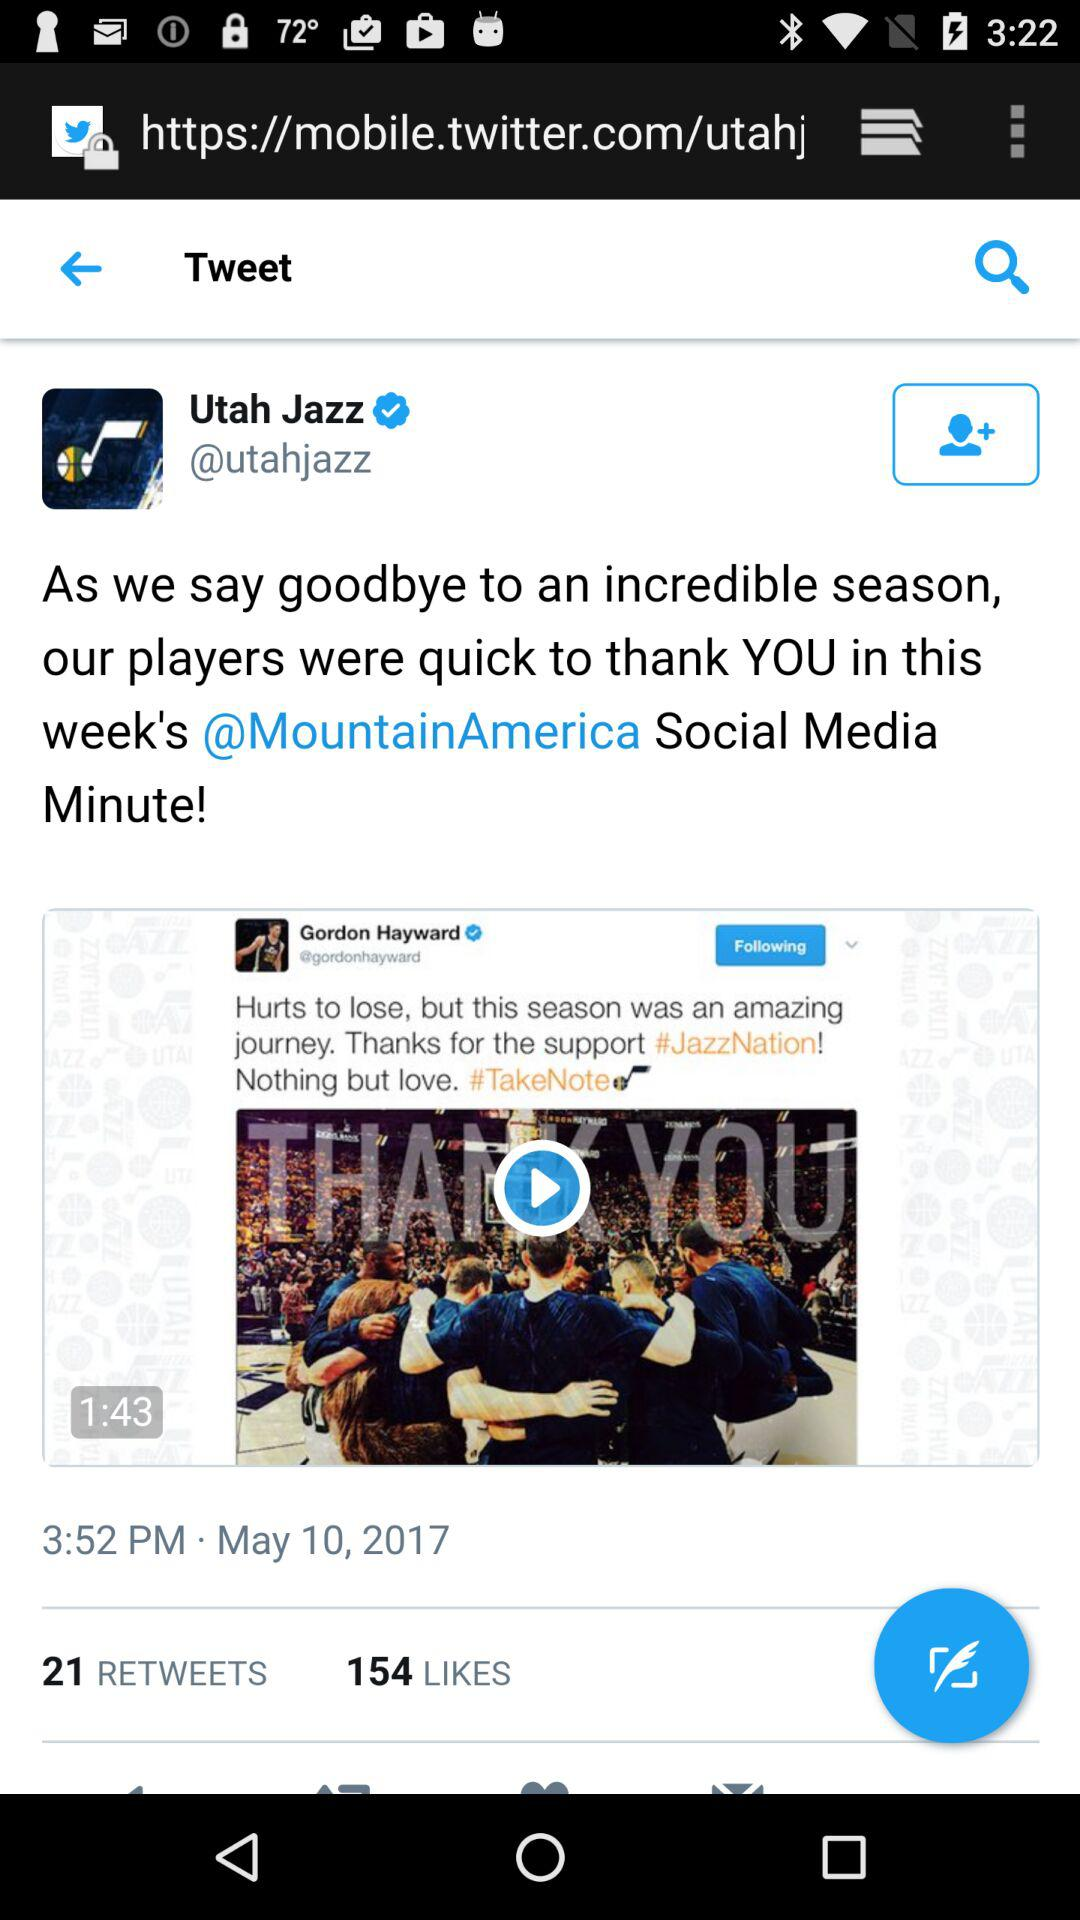How many comments are there on the post?
When the provided information is insufficient, respond with <no answer>. <no answer> 